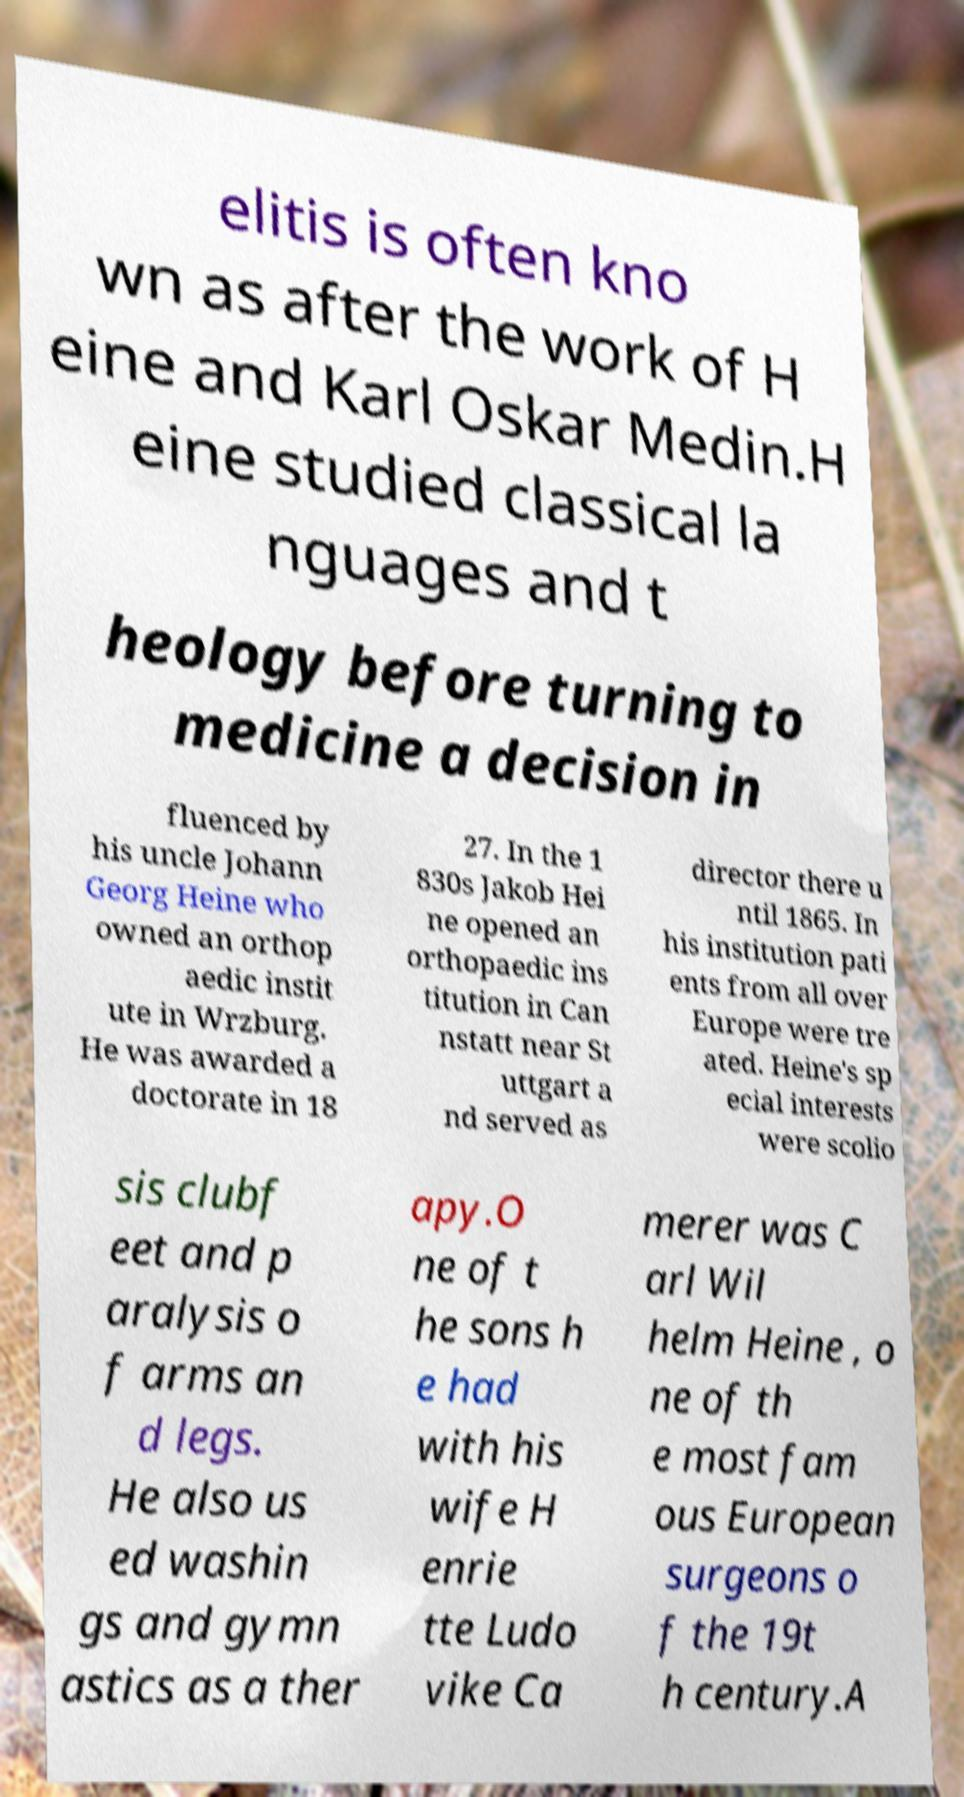Could you extract and type out the text from this image? elitis is often kno wn as after the work of H eine and Karl Oskar Medin.H eine studied classical la nguages and t heology before turning to medicine a decision in fluenced by his uncle Johann Georg Heine who owned an orthop aedic instit ute in Wrzburg. He was awarded a doctorate in 18 27. In the 1 830s Jakob Hei ne opened an orthopaedic ins titution in Can nstatt near St uttgart a nd served as director there u ntil 1865. In his institution pati ents from all over Europe were tre ated. Heine's sp ecial interests were scolio sis clubf eet and p aralysis o f arms an d legs. He also us ed washin gs and gymn astics as a ther apy.O ne of t he sons h e had with his wife H enrie tte Ludo vike Ca merer was C arl Wil helm Heine , o ne of th e most fam ous European surgeons o f the 19t h century.A 